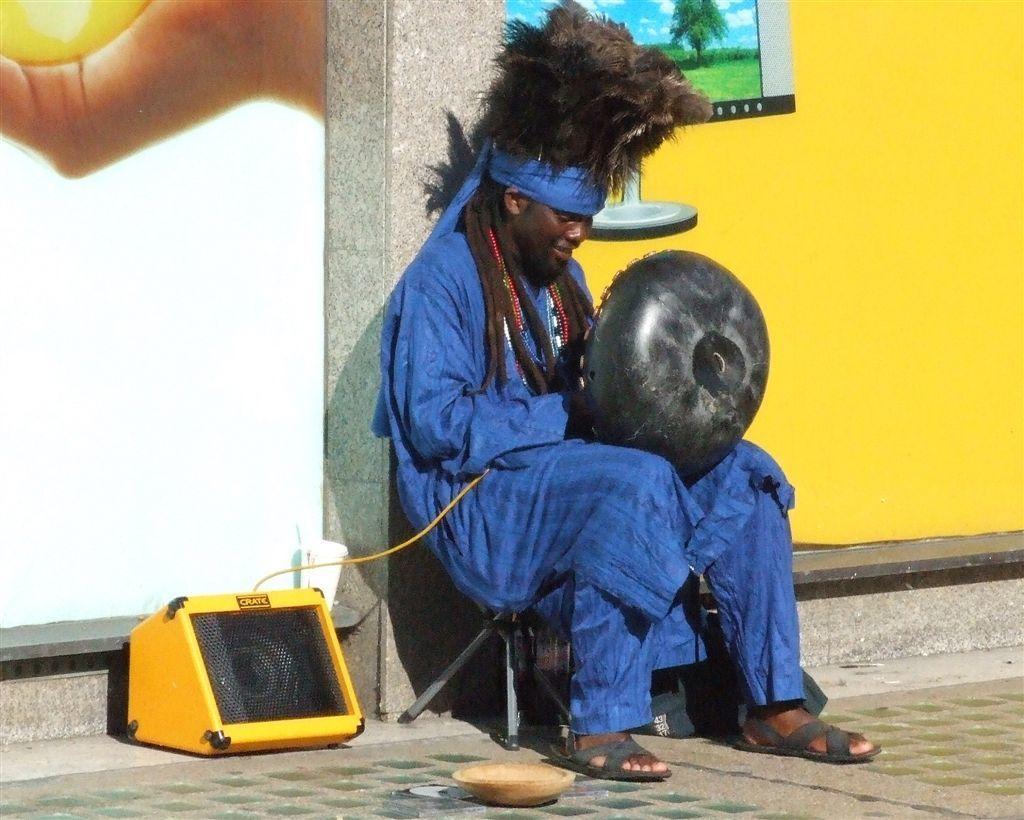Describe this image in one or two sentences. In this image there is a man sitting on a stool. He is holding an object. Beside him there is a speaker. Behind him there is a wall. There are pictures on the wall. 